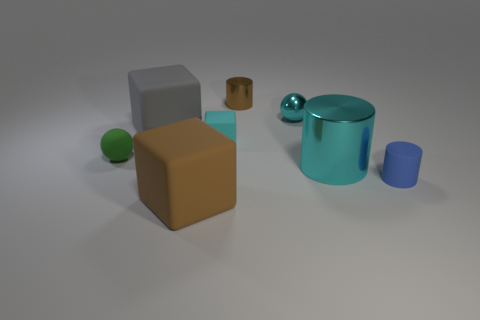Subtract all small cylinders. How many cylinders are left? 1 Add 1 tiny gray shiny spheres. How many objects exist? 9 Subtract all cylinders. How many objects are left? 5 Subtract all yellow cubes. Subtract all purple cylinders. How many cubes are left? 3 Subtract 0 yellow cubes. How many objects are left? 8 Subtract all cyan cylinders. Subtract all tiny blue cylinders. How many objects are left? 6 Add 6 tiny green things. How many tiny green things are left? 7 Add 2 big gray cubes. How many big gray cubes exist? 3 